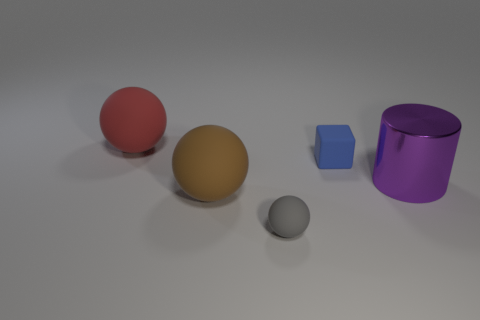Is there any other thing that is the same material as the cylinder?
Keep it short and to the point. No. There is a object that is both on the right side of the gray matte sphere and to the left of the large purple metallic cylinder; what shape is it?
Offer a very short reply. Cube. There is a brown matte object; is it the same shape as the small rubber object that is on the right side of the small gray rubber thing?
Offer a very short reply. No. Are there any brown balls on the left side of the large red object?
Provide a succinct answer. No. What number of cylinders are tiny gray objects or blue rubber objects?
Offer a very short reply. 0. Is the tiny gray matte object the same shape as the purple object?
Keep it short and to the point. No. How big is the red rubber sphere behind the shiny cylinder?
Keep it short and to the point. Large. Are there any big rubber cylinders of the same color as the block?
Make the answer very short. No. Do the rubber thing that is right of the gray rubber thing and the red sphere have the same size?
Your answer should be compact. No. What color is the big cylinder?
Make the answer very short. Purple. 